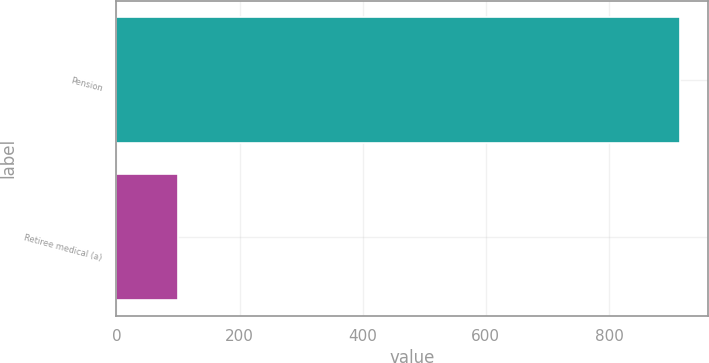Convert chart. <chart><loc_0><loc_0><loc_500><loc_500><bar_chart><fcel>Pension<fcel>Retiree medical (a)<nl><fcel>915<fcel>100<nl></chart> 